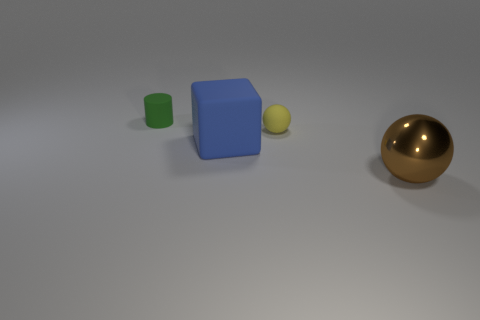Add 1 blue metal objects. How many objects exist? 5 Subtract all cylinders. How many objects are left? 3 Add 2 big brown cubes. How many big brown cubes exist? 2 Subtract 0 yellow cylinders. How many objects are left? 4 Subtract all yellow balls. Subtract all big metal spheres. How many objects are left? 2 Add 3 blocks. How many blocks are left? 4 